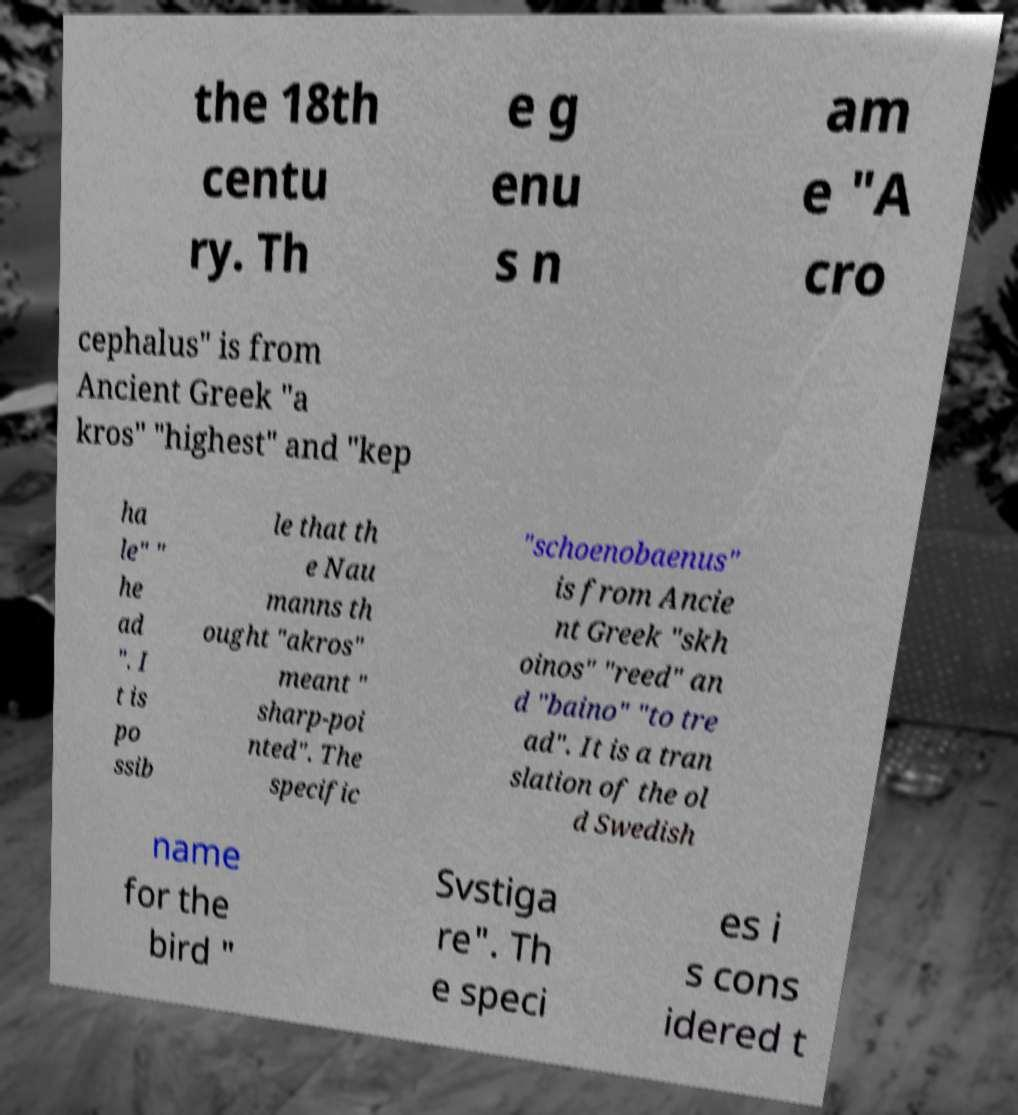Please identify and transcribe the text found in this image. the 18th centu ry. Th e g enu s n am e "A cro cephalus" is from Ancient Greek "a kros" "highest" and "kep ha le" " he ad ". I t is po ssib le that th e Nau manns th ought "akros" meant " sharp-poi nted". The specific "schoenobaenus" is from Ancie nt Greek "skh oinos" "reed" an d "baino" "to tre ad". It is a tran slation of the ol d Swedish name for the bird " Svstiga re". Th e speci es i s cons idered t 